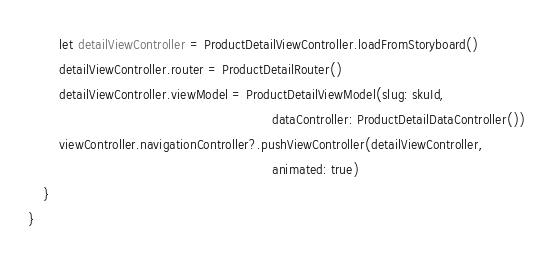<code> <loc_0><loc_0><loc_500><loc_500><_Swift_>
        let detailViewController = ProductDetailViewController.loadFromStoryboard()
        detailViewController.router = ProductDetailRouter()
        detailViewController.viewModel = ProductDetailViewModel(slug: skuId,
                                                                dataController: ProductDetailDataController())
        viewController.navigationController?.pushViewController(detailViewController,
                                                                animated: true)
    }
}
</code> 